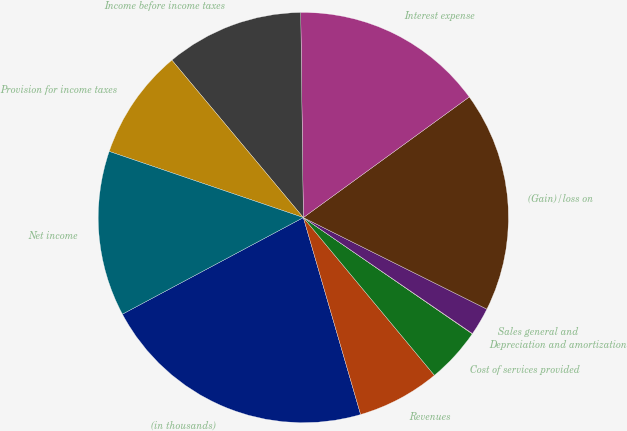<chart> <loc_0><loc_0><loc_500><loc_500><pie_chart><fcel>(in thousands)<fcel>Revenues<fcel>Cost of services provided<fcel>Depreciation and amortization<fcel>Sales general and<fcel>(Gain)/loss on<fcel>Interest expense<fcel>Income before income taxes<fcel>Provision for income taxes<fcel>Net income<nl><fcel>21.7%<fcel>6.53%<fcel>4.37%<fcel>0.03%<fcel>2.2%<fcel>17.37%<fcel>15.2%<fcel>10.87%<fcel>8.7%<fcel>13.03%<nl></chart> 